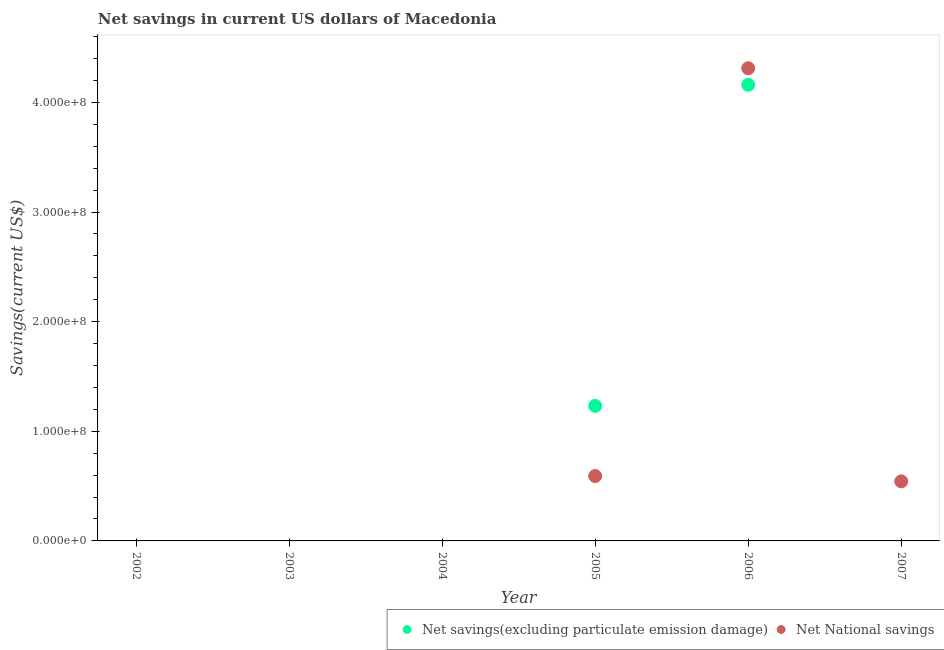Is the number of dotlines equal to the number of legend labels?
Keep it short and to the point. No. What is the net national savings in 2007?
Make the answer very short. 5.43e+07. Across all years, what is the maximum net savings(excluding particulate emission damage)?
Your answer should be very brief. 4.16e+08. Across all years, what is the minimum net savings(excluding particulate emission damage)?
Your answer should be very brief. 0. In which year was the net savings(excluding particulate emission damage) maximum?
Give a very brief answer. 2006. What is the total net national savings in the graph?
Provide a succinct answer. 5.45e+08. What is the difference between the net national savings in 2005 and that in 2007?
Make the answer very short. 4.86e+06. What is the difference between the net national savings in 2003 and the net savings(excluding particulate emission damage) in 2002?
Offer a terse response. 0. What is the average net national savings per year?
Ensure brevity in your answer.  9.08e+07. In the year 2006, what is the difference between the net national savings and net savings(excluding particulate emission damage)?
Give a very brief answer. 1.51e+07. What is the ratio of the net savings(excluding particulate emission damage) in 2005 to that in 2006?
Keep it short and to the point. 0.3. What is the difference between the highest and the second highest net national savings?
Offer a terse response. 3.72e+08. What is the difference between the highest and the lowest net savings(excluding particulate emission damage)?
Your answer should be very brief. 4.16e+08. Is the net national savings strictly less than the net savings(excluding particulate emission damage) over the years?
Your response must be concise. No. How many dotlines are there?
Offer a terse response. 2. What is the difference between two consecutive major ticks on the Y-axis?
Your response must be concise. 1.00e+08. Where does the legend appear in the graph?
Your response must be concise. Bottom right. How are the legend labels stacked?
Keep it short and to the point. Horizontal. What is the title of the graph?
Offer a terse response. Net savings in current US dollars of Macedonia. What is the label or title of the Y-axis?
Offer a very short reply. Savings(current US$). What is the Savings(current US$) of Net savings(excluding particulate emission damage) in 2002?
Keep it short and to the point. 0. What is the Savings(current US$) of Net National savings in 2002?
Provide a succinct answer. 0. What is the Savings(current US$) of Net savings(excluding particulate emission damage) in 2003?
Offer a terse response. 0. What is the Savings(current US$) in Net National savings in 2003?
Ensure brevity in your answer.  0. What is the Savings(current US$) of Net National savings in 2004?
Offer a very short reply. 0. What is the Savings(current US$) in Net savings(excluding particulate emission damage) in 2005?
Offer a terse response. 1.23e+08. What is the Savings(current US$) of Net National savings in 2005?
Give a very brief answer. 5.92e+07. What is the Savings(current US$) of Net savings(excluding particulate emission damage) in 2006?
Your answer should be compact. 4.16e+08. What is the Savings(current US$) in Net National savings in 2006?
Keep it short and to the point. 4.31e+08. What is the Savings(current US$) of Net National savings in 2007?
Your response must be concise. 5.43e+07. Across all years, what is the maximum Savings(current US$) in Net savings(excluding particulate emission damage)?
Keep it short and to the point. 4.16e+08. Across all years, what is the maximum Savings(current US$) in Net National savings?
Provide a succinct answer. 4.31e+08. Across all years, what is the minimum Savings(current US$) in Net savings(excluding particulate emission damage)?
Ensure brevity in your answer.  0. What is the total Savings(current US$) of Net savings(excluding particulate emission damage) in the graph?
Provide a succinct answer. 5.39e+08. What is the total Savings(current US$) of Net National savings in the graph?
Your answer should be compact. 5.45e+08. What is the difference between the Savings(current US$) of Net savings(excluding particulate emission damage) in 2005 and that in 2006?
Provide a short and direct response. -2.93e+08. What is the difference between the Savings(current US$) of Net National savings in 2005 and that in 2006?
Your answer should be compact. -3.72e+08. What is the difference between the Savings(current US$) in Net National savings in 2005 and that in 2007?
Your answer should be very brief. 4.86e+06. What is the difference between the Savings(current US$) of Net National savings in 2006 and that in 2007?
Offer a terse response. 3.77e+08. What is the difference between the Savings(current US$) of Net savings(excluding particulate emission damage) in 2005 and the Savings(current US$) of Net National savings in 2006?
Your response must be concise. -3.08e+08. What is the difference between the Savings(current US$) of Net savings(excluding particulate emission damage) in 2005 and the Savings(current US$) of Net National savings in 2007?
Give a very brief answer. 6.89e+07. What is the difference between the Savings(current US$) in Net savings(excluding particulate emission damage) in 2006 and the Savings(current US$) in Net National savings in 2007?
Give a very brief answer. 3.62e+08. What is the average Savings(current US$) in Net savings(excluding particulate emission damage) per year?
Offer a terse response. 8.99e+07. What is the average Savings(current US$) in Net National savings per year?
Offer a terse response. 9.08e+07. In the year 2005, what is the difference between the Savings(current US$) in Net savings(excluding particulate emission damage) and Savings(current US$) in Net National savings?
Your answer should be very brief. 6.40e+07. In the year 2006, what is the difference between the Savings(current US$) of Net savings(excluding particulate emission damage) and Savings(current US$) of Net National savings?
Provide a succinct answer. -1.51e+07. What is the ratio of the Savings(current US$) of Net savings(excluding particulate emission damage) in 2005 to that in 2006?
Your response must be concise. 0.3. What is the ratio of the Savings(current US$) in Net National savings in 2005 to that in 2006?
Provide a short and direct response. 0.14. What is the ratio of the Savings(current US$) of Net National savings in 2005 to that in 2007?
Provide a short and direct response. 1.09. What is the ratio of the Savings(current US$) of Net National savings in 2006 to that in 2007?
Make the answer very short. 7.94. What is the difference between the highest and the second highest Savings(current US$) of Net National savings?
Offer a very short reply. 3.72e+08. What is the difference between the highest and the lowest Savings(current US$) in Net savings(excluding particulate emission damage)?
Offer a terse response. 4.16e+08. What is the difference between the highest and the lowest Savings(current US$) of Net National savings?
Provide a short and direct response. 4.31e+08. 